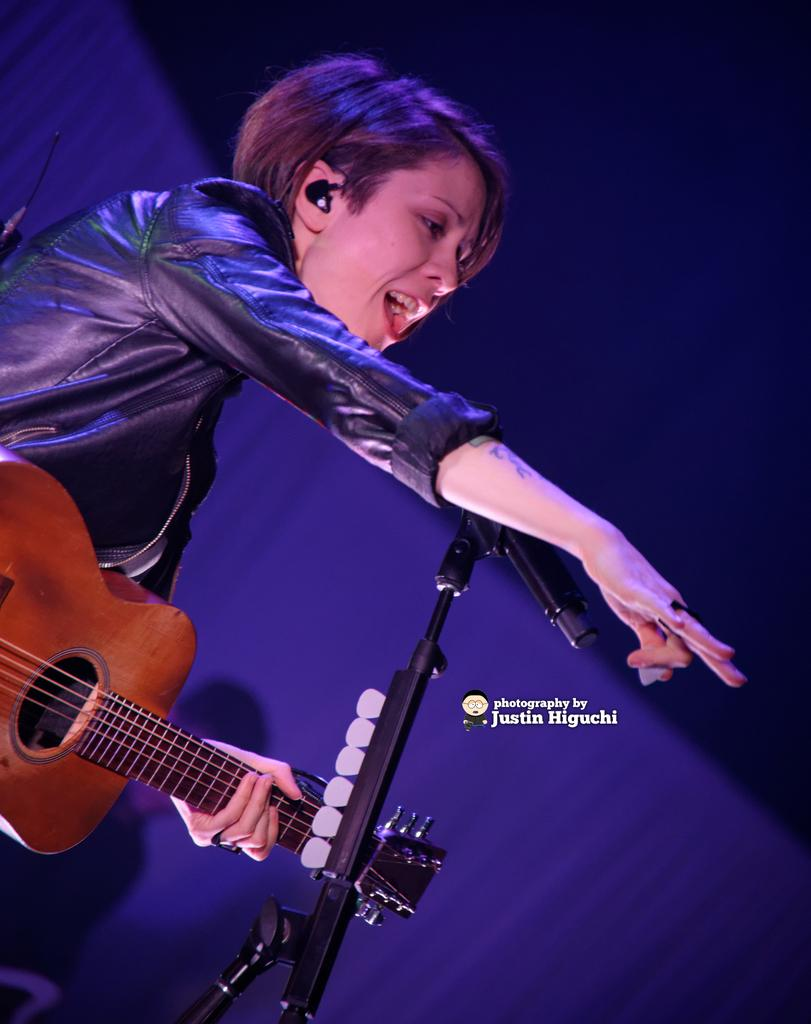Who is the main subject in the image? There is a woman in the image. What is the woman doing in the image? The woman is singing and playing a guitar. What is the woman using to amplify her voice in the image? There is a microphone in the image, which is on a stand. What color is the background in the image? The background of the image is blue. What is the woman wearing in the image? The woman is wearing a black jacket. What type of match is the woman playing in the image? There is no match or any reference to a match in the image; it features a woman singing and playing a guitar. Is the woman a spy in the image? There is no indication in the image that the woman is a spy or involved in any espionage activities. 